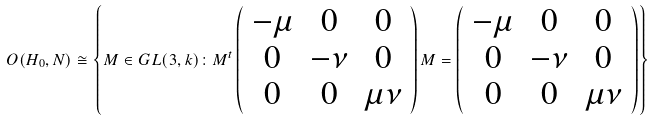Convert formula to latex. <formula><loc_0><loc_0><loc_500><loc_500>O ( H _ { 0 } , N ) \cong \left \{ M \in G L ( 3 , k ) \colon M ^ { t } \left ( \begin{array} { c c c } - \mu & 0 & 0 \\ 0 & - \nu & 0 \\ 0 & 0 & \mu \nu \end{array} \right ) M = \left ( \begin{array} { c c c } - \mu & 0 & 0 \\ 0 & - \nu & 0 \\ 0 & 0 & \mu \nu \end{array} \right ) \right \}</formula> 